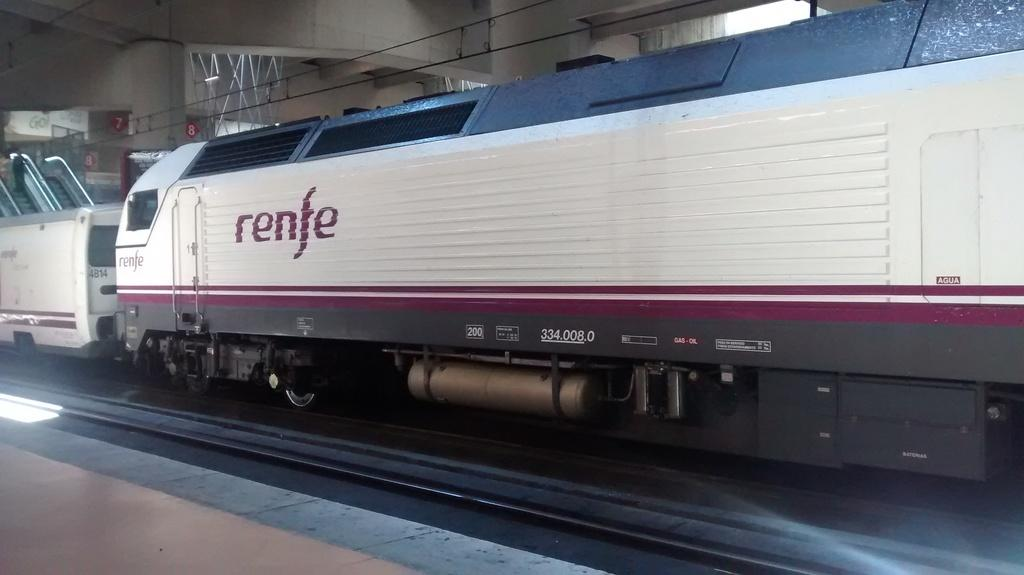What is the main subject of the image? The main subject of the image is a train. Where is the train located in the image? The train is on a railway track in the image. What is the position of the railway track in the image? The railway track is in the middle of the image. What other structure is visible in the image? There is a platform in the image. Where is the platform located in the image? The platform is at the bottom of the image. Can you tell me how many ministers are standing on the platform in the image? There are no ministers present in the image; it only features a train, railway track, and platform. Is there a boy playing with a toy train on the platform in the image? There is no boy or toy train visible on the platform in the image. 